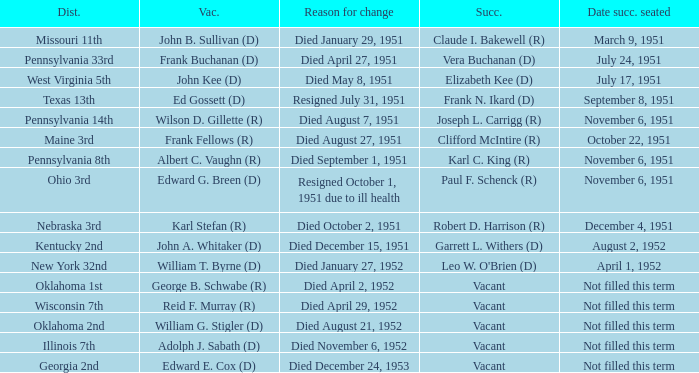How many vacators were in the Pennsylvania 33rd district? 1.0. 